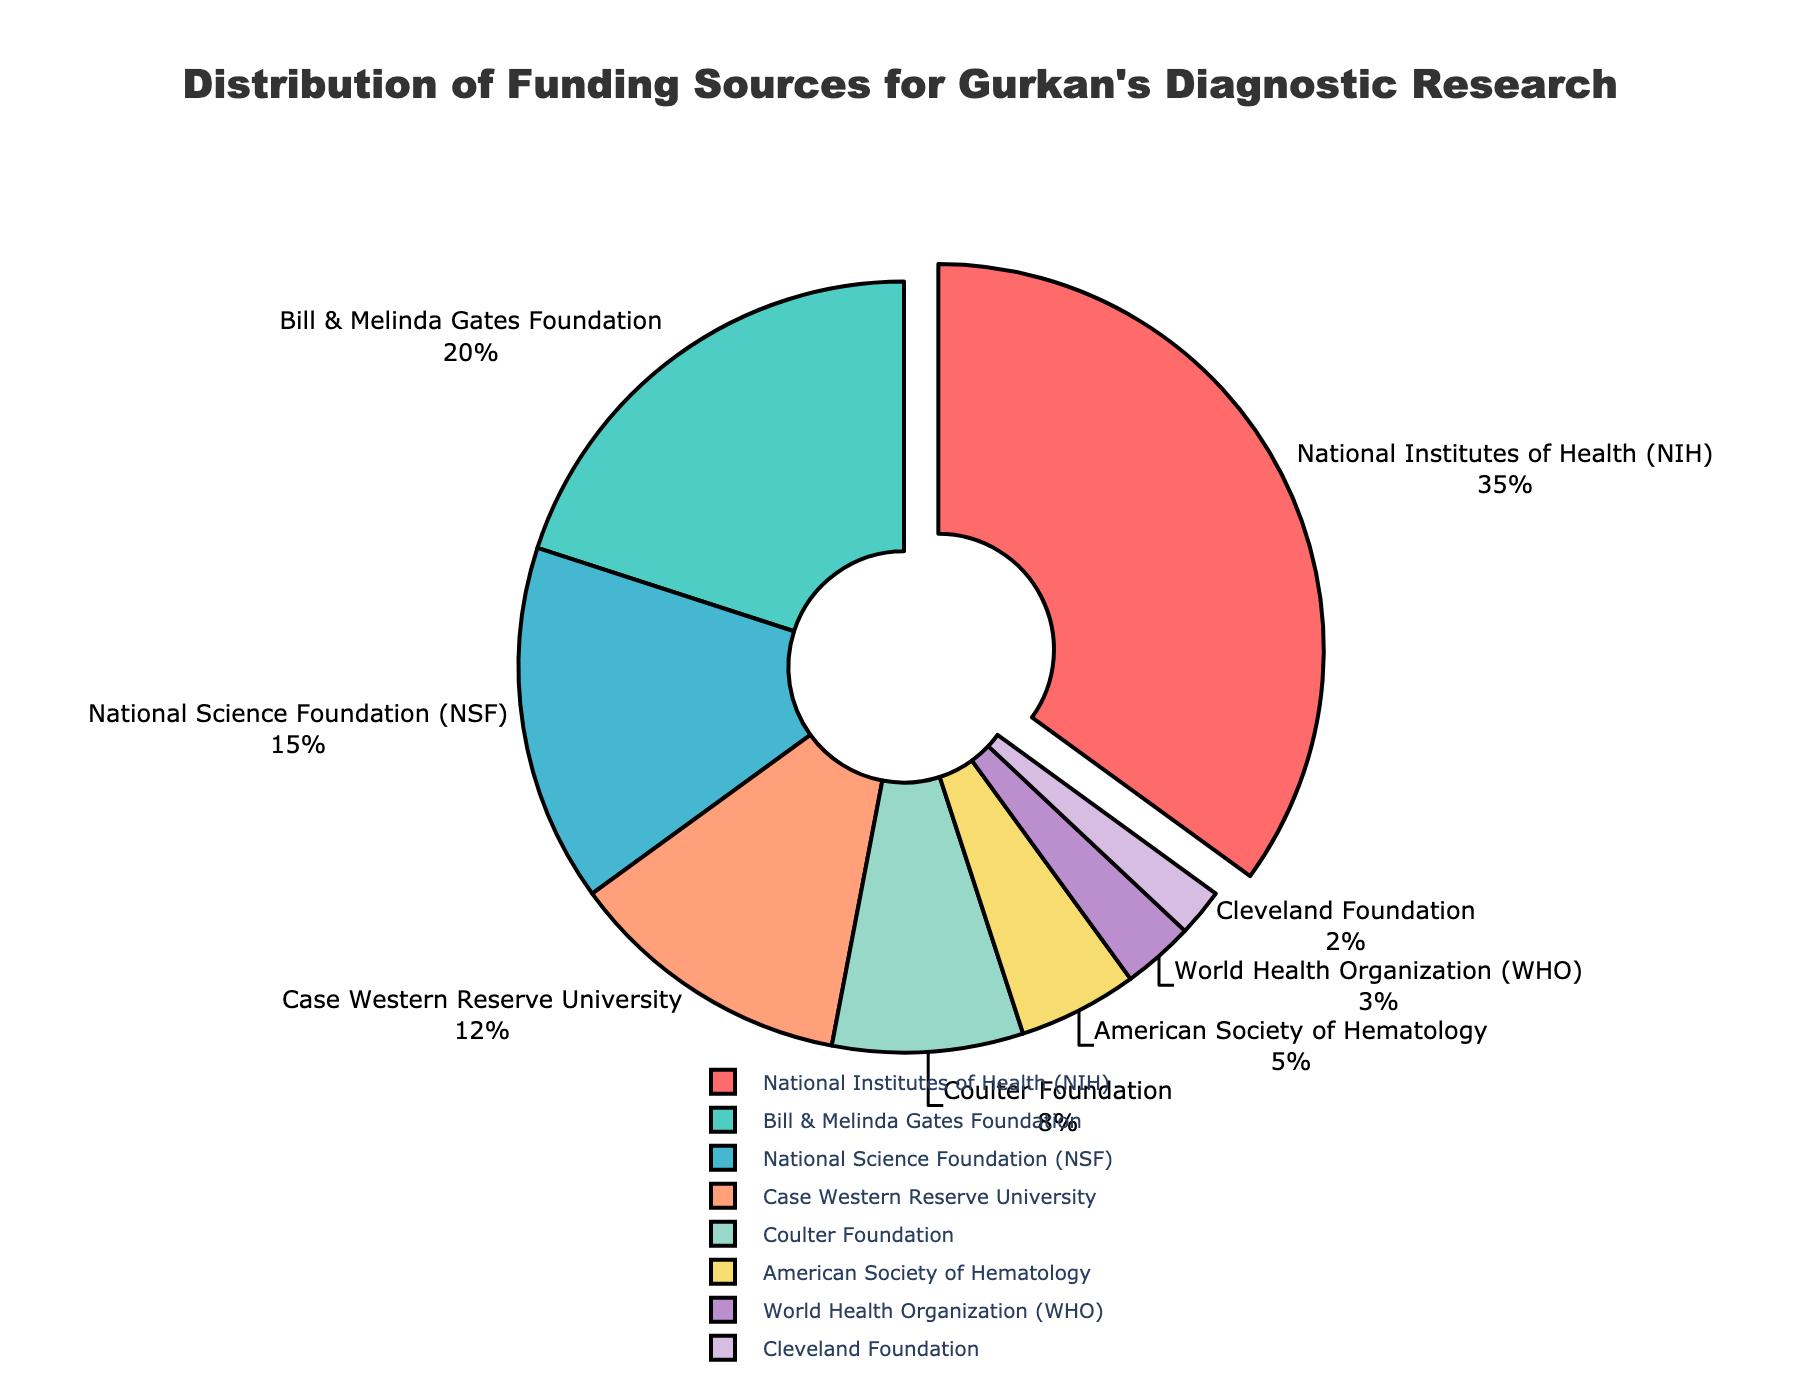Which funding source contributes the highest percentage? The "National Institutes of Health (NIH)" segment is visually highlighted by being pulled out slightly from the pie chart. It accounts for 35% of the funding.
Answer: National Institutes of Health (NIH) What is the combined percentage of funding from the National Science Foundation (NSF) and the Coulter Foundation? The National Science Foundation (NSF) contributes 15% and the Coulter Foundation contributes 8%. Adding these together, 15% + 8% = 23%.
Answer: 23% Which two foundations contribute exactly 20% and 8% to the funding, respectively? The labels outside the pie chart indicate that the Bill & Melinda Gates Foundation contributes 20% and the Coulter Foundation contributes 8% to the funding.
Answer: Bill & Melinda Gates Foundation, Coulter Foundation How much percent do the smallest three funding sources contribute combined? The smallest three funding sources are the World Health Organization (WHO) with 3%, Cleveland Foundation with 2%, and the American Society of Hematology with 5%. Adding these together, 3% + 2% + 5% = 10%.
Answer: 10% Which funding source is represented by the purple section of the pie chart? The purple section of the pie chart corresponds to the World Health Organization (WHO), which is visually indicated by its label and color association.
Answer: World Health Organization (WHO) How much more does the National Institutes of Health (NIH) contribute compared to Case Western Reserve University? The National Institutes of Health (NIH) contributes 35%, and Case Western Reserve University contributes 12%. Subtracting these gives 35% - 12% = 23%.
Answer: 23% Which section of the pie chart is the smallest, and what is its percentage? The label outside the pie chart shows that the Cleveland Foundation is the smallest section, contributing 2% of the total funding.
Answer: Cleveland Foundation, 2% How much more funding does the Bill & Melinda Gates Foundation provide compared to the World Health Organization (WHO)? The Bill & Melinda Gates Foundation provides 20%, while the World Health Organization (WHO) provides 3%. Subtracting these gives 20% - 3% = 17%.
Answer: 17% Which sections of the chart are marked by shades of green, and what are their percentages? The segments marked by shades of green are the Bill & Melinda Gates Foundation at 20% and the American Society of Hematology at 5%.
Answer: Bill & Melinda Gates Foundation (20%), American Society of Hematology (5%) By what percentage does the funding from the National Science Foundation (NSF) exceed the funding from the American Society of Hematology? The National Science Foundation (NSF) provides 15%, whereas the American Society of Hematology provides 5%. Subtracting these gives 15% - 5% = 10%.
Answer: 10% 